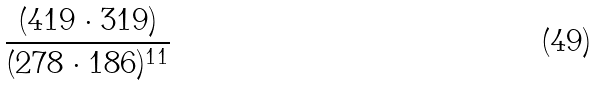Convert formula to latex. <formula><loc_0><loc_0><loc_500><loc_500>\frac { ( 4 1 9 \cdot 3 1 9 ) } { ( 2 7 8 \cdot 1 8 6 ) ^ { 1 1 } }</formula> 